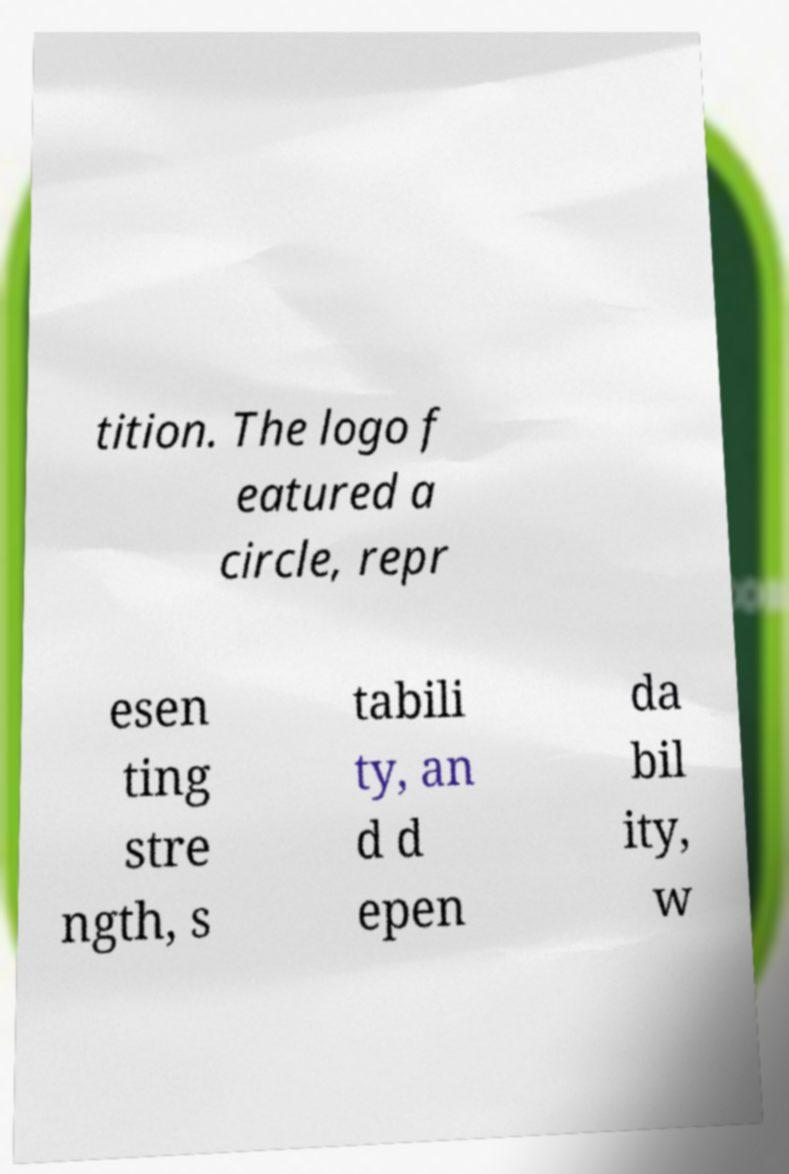Could you extract and type out the text from this image? tition. The logo f eatured a circle, repr esen ting stre ngth, s tabili ty, an d d epen da bil ity, w 